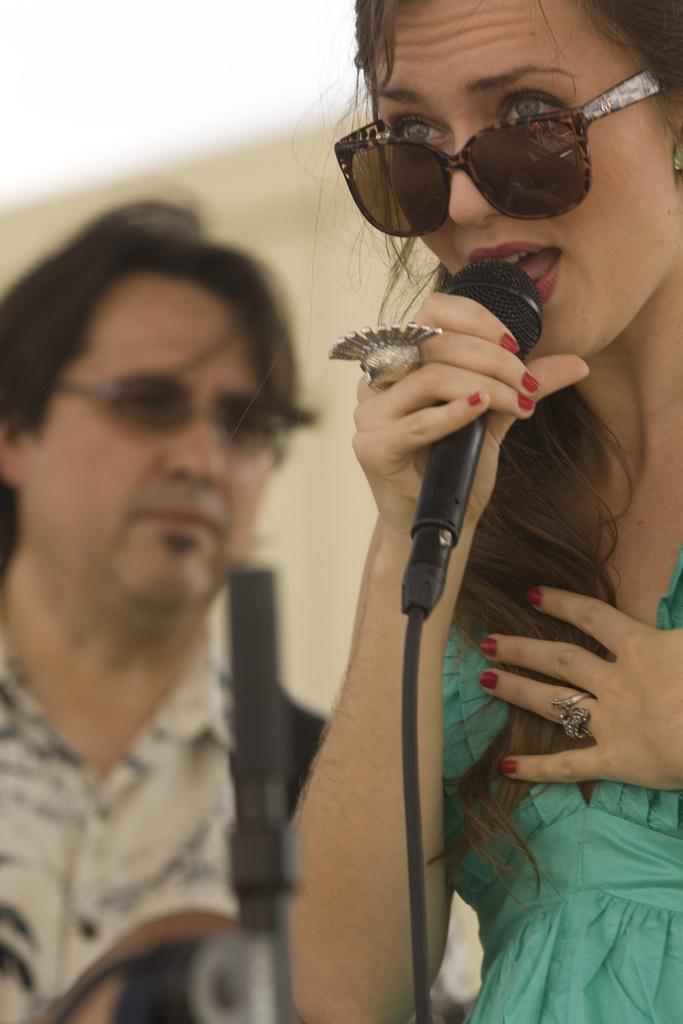Who is the main subject in the image? There is a woman in the image. What is the woman holding in the image? The woman is holding a microphone. What type of protective eyewear is the woman wearing? The woman is wearing goggles. Are there any other people in the image? Yes, there is a man in the image. What type of idea is the woman expressing through her jeans in the image? There is no mention of jeans in the image, and the woman is not expressing any ideas through clothing. 